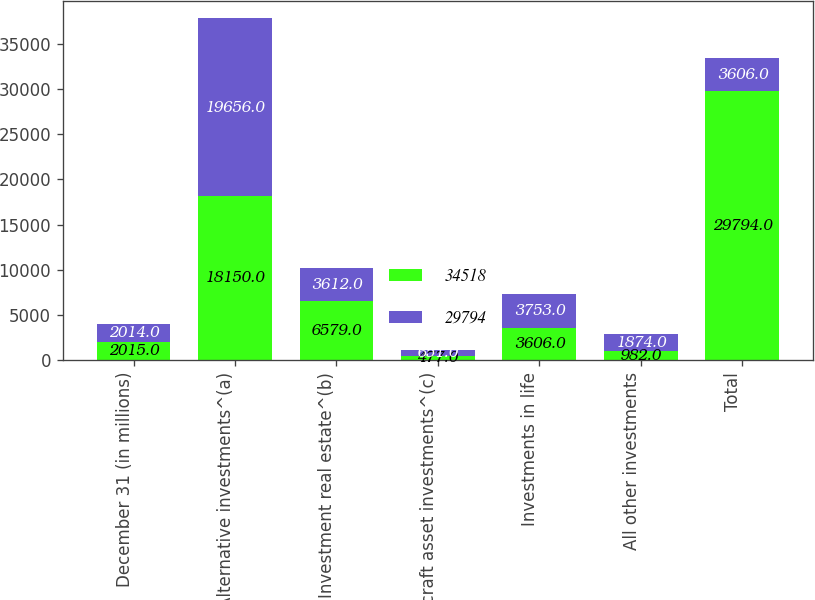<chart> <loc_0><loc_0><loc_500><loc_500><stacked_bar_chart><ecel><fcel>December 31 (in millions)<fcel>Alternative investments^(a)<fcel>Investment real estate^(b)<fcel>Aircraft asset investments^(c)<fcel>Investments in life<fcel>All other investments<fcel>Total<nl><fcel>34518<fcel>2015<fcel>18150<fcel>6579<fcel>477<fcel>3606<fcel>982<fcel>29794<nl><fcel>29794<fcel>2014<fcel>19656<fcel>3612<fcel>651<fcel>3753<fcel>1874<fcel>3606<nl></chart> 